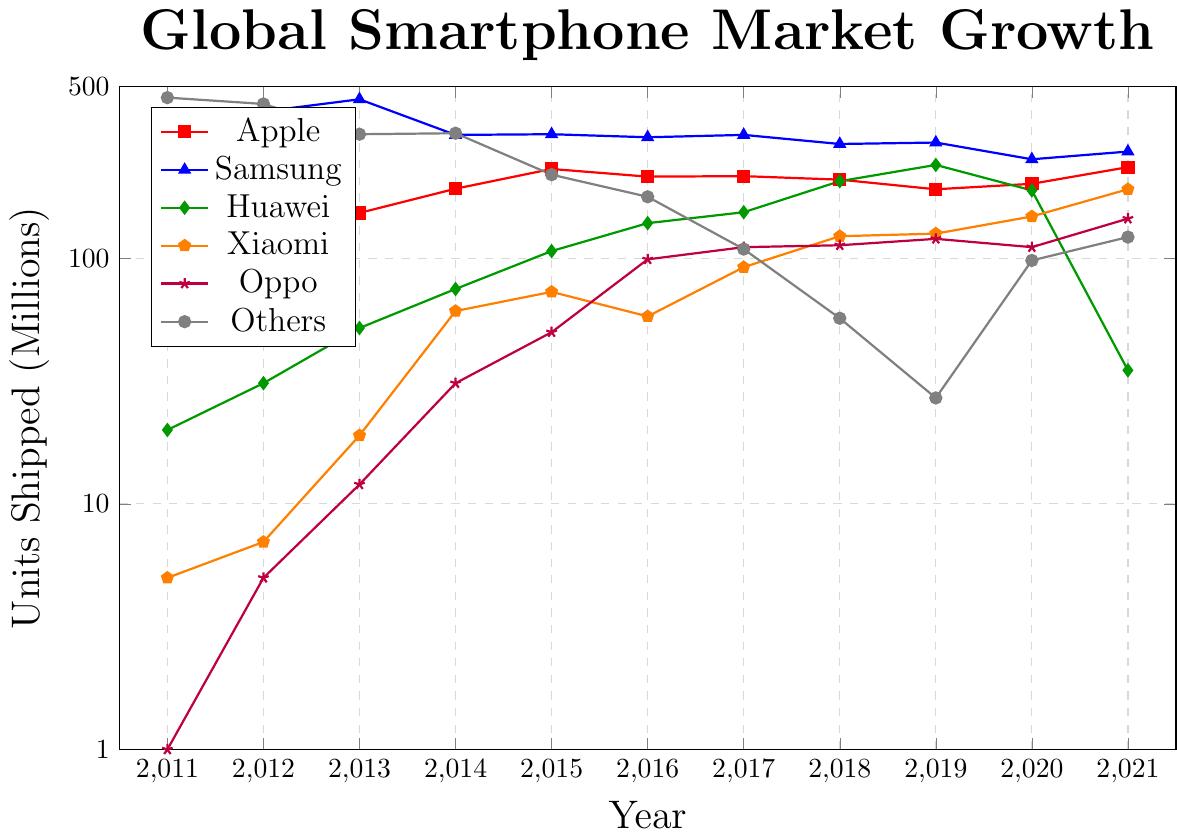Which brand shipped the highest number of units in 2011? Look at the y-axis values for 2011 and identify the tallest line segment, which corresponds to the brand 'Others' with 451 units.
Answer: Others How did Apple’s units shipped change between 2018 and 2021? Calculate the difference between Apple's shipments in 2018 (209) and 2021 (235). The difference is 235 - 209 = 26 units.
Answer: Increased by 26 units Which two brands showed the most proportional growth between 2011 and 2021? Compare the ratios of units shipped in 2021 to those in 2011 for each brand. Huawei grew from 20 to 35 (ratio ~1.75), Xiaomi from 5 to 191 (ratio ~38.2), and Oppo from 1 to 145 (ratio ~145). Xiaomi and Oppo showed the most substantial proportional growth.
Answer: Xiaomi and Oppo What is the approximate total units shipped by Samsung from 2018 to 2021? Sum the values for Samsung from 2018 to 2021: 292 + 296 + 253 + 272 = 1113 units.
Answer: 1113 units Which brand experienced the most significant decline in units shipped from 2019 to 2021? Examine the differences from 2019 to 2021 for each brand. Huawei showed a significant decline from 240 to 35, a drop of 205 units.
Answer: Huawei In which year did Huawei reach its peak units shipped? Look at the y-axis values for Huawei over the years and identify its highest point, which occurs in 2019 with 240 units.
Answer: 2019 How does the range of units shipped by Xiaomi compare to that of Oppo? For Xiaomi, the range is 2011 to 2021 (5 to 191), so 191 - 5 = 186 units. For Oppo, the range is 1 to 145, so 145 - 1 = 144 units. Xiaomi's range is greater.
Answer: Xiaomi has a greater range Which year did Samsung have the least units shipped within the decade? Find the smallest value for Samsung from the data, which is 253 in 2020.
Answer: 2020 What visual difference can you observe in the growth pattern between Apple and Huawei? Apple's growth pattern is fairly steady with slight fluctuations, whereas Huawei shows a rapid increase until 2019 followed by a sharp drop.
Answer: Apple: steady, Huawei: rapid increase then sharp drop 